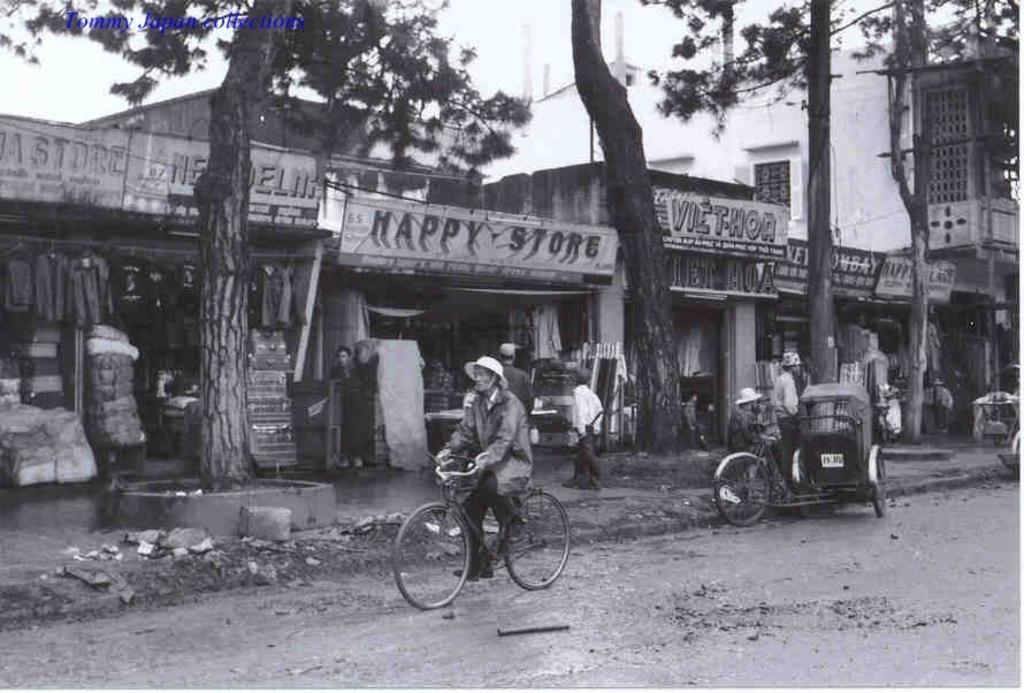Please provide a concise description of this image. This is a black and white image. I can see a man wearing a hat and riding bicycle. I can see two persons standing beside the road. I Think this is a kind of rickshaw. At background I can see stores and shops. This is the name board of the store. This is the tall tree with big trunk. At the right corner of the image I can see a building. I can see a man standing in front of the store. 